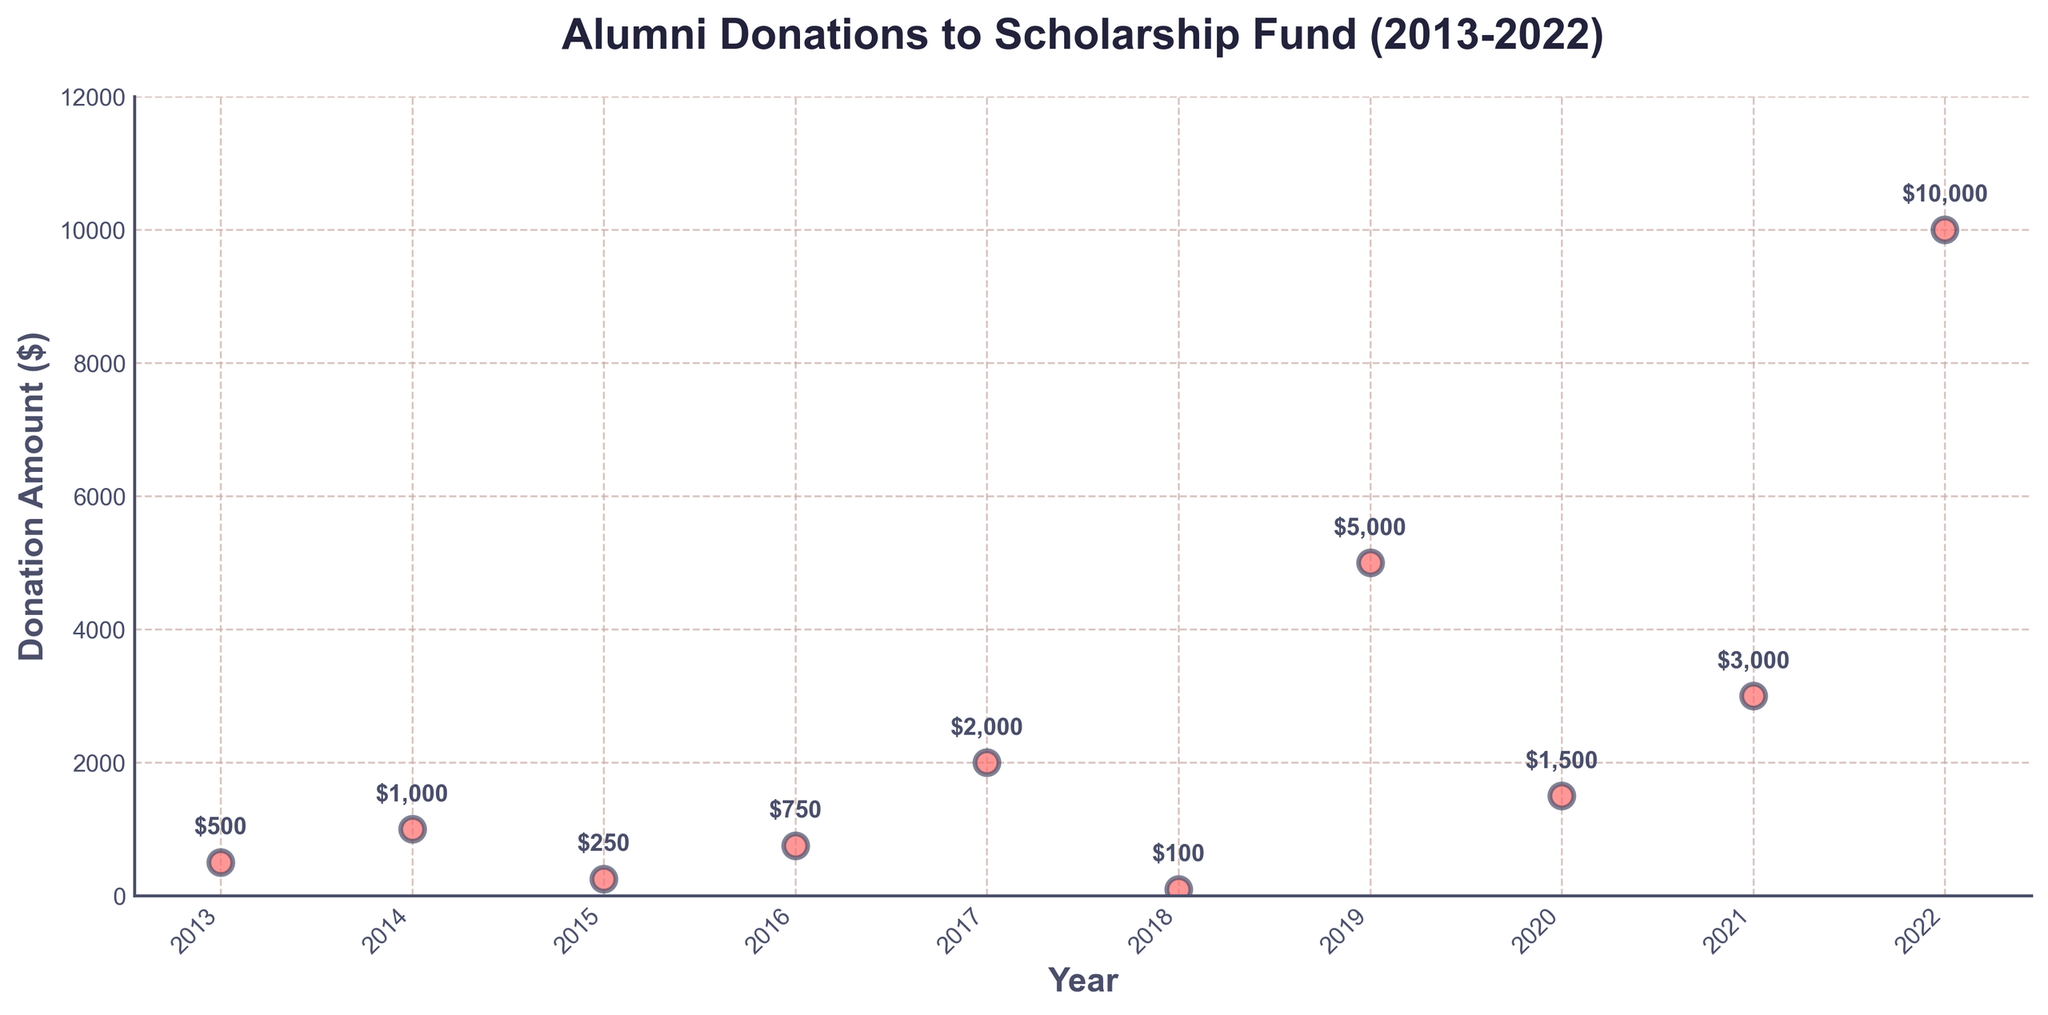What is the title of the plot? The title can be found at the top of the plot. It is "Alumni Donations to Scholarship Fund (2013-2022)".
Answer: Alumni Donations to Scholarship Fund (2013-2022) What are the labels on the x-axis and y-axis? The x-axis label is found along the horizontal axis and the y-axis label is along the vertical axis. The labels are "Year" for the x-axis and "Donation Amount ($)" for the y-axis.
Answer: Year, Donation Amount ($) In which year did the alumni donate the highest amount, and what was the amount? The highest donation can be found by looking at the uppermost point on the plot. The year corresponding to this point is annotated with "10000" which is the highest donation amount in 2022.
Answer: 2022, $10,000 Which year had the lowest alumni donation, and what was the amount? The lowest donation can be found by looking at the lowest point on the plot. The year corresponding to this point is annotated with "100" which is the lowest donation amount in 2018.
Answer: 2018, $100 What is the range of donation amounts? To find the range, subtract the smallest donation amount from the largest. The highest donation is $10,000 (2022) and the lowest is $100 (2018). The range is $10,000 - $100.
Answer: $9,900 How did the donation amount in 2021 compare to that in 2020? To compare, look for the points in 2020 and 2021. The amount in 2020 is $1,500 and in 2021 is $3,000. $3,000 is greater than $1,500.
Answer: Higher What is the average donation amount over the given years? Add all donation amounts and divide by the number of years. The amounts are 500 + 1000 + 250 + 750 + 2000 + 100 + 5000 + 1500 + 3000 + 10000 = 22,100. The number of years is 10. The average donation is 22,100 / 10.
Answer: $2,210 How many donations were over $2,000? Count the points above the $2,000 mark. The years are 2017 ($2,000), 2019 ($5,000), 2021 ($3,000), and 2022 ($10,000). There are 4 points.
Answer: 4 What was the cumulative donation amount from 2017 to 2019? Add the donation amounts for the years 2017, 2018, and 2019. The amounts are 2000 (2017), 100 (2018), and 5000 (2019). Add them up: 2000 + 100 + 5000 = 7100.
Answer: $7,100 